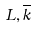<formula> <loc_0><loc_0><loc_500><loc_500>L , \overline { k }</formula> 